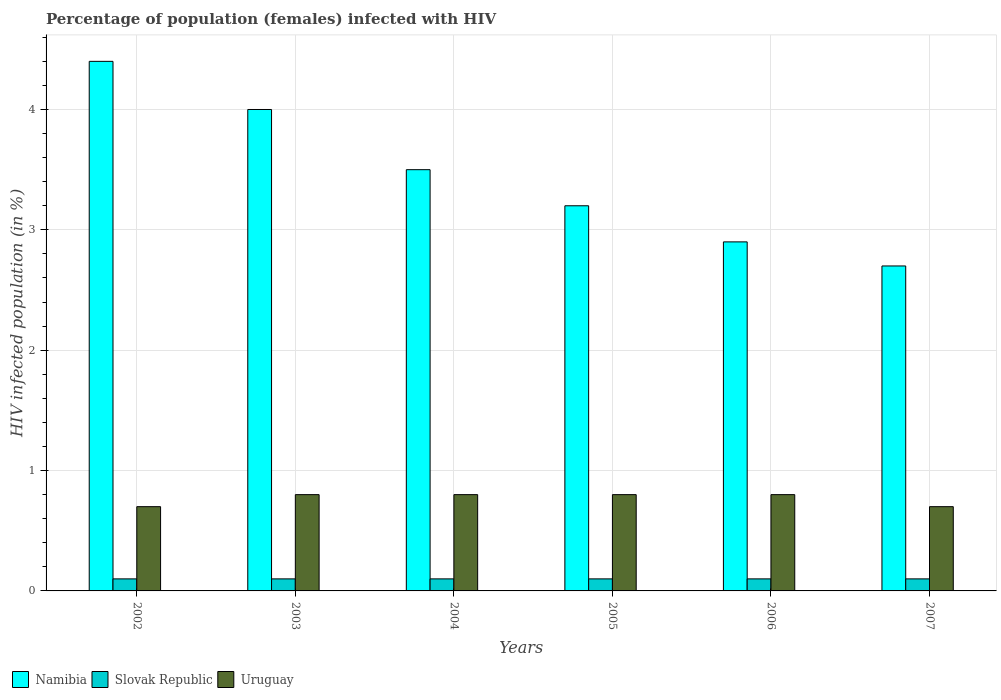How many groups of bars are there?
Provide a short and direct response. 6. Are the number of bars per tick equal to the number of legend labels?
Keep it short and to the point. Yes. Are the number of bars on each tick of the X-axis equal?
Offer a very short reply. Yes. What is the label of the 4th group of bars from the left?
Your answer should be compact. 2005. What is the percentage of HIV infected female population in Namibia in 2002?
Make the answer very short. 4.4. Across all years, what is the maximum percentage of HIV infected female population in Namibia?
Ensure brevity in your answer.  4.4. Across all years, what is the minimum percentage of HIV infected female population in Namibia?
Your answer should be compact. 2.7. In which year was the percentage of HIV infected female population in Slovak Republic maximum?
Give a very brief answer. 2002. What is the difference between the percentage of HIV infected female population in Slovak Republic in 2006 and that in 2007?
Your answer should be compact. 0. What is the difference between the percentage of HIV infected female population in Namibia in 2007 and the percentage of HIV infected female population in Slovak Republic in 2002?
Make the answer very short. 2.6. What is the average percentage of HIV infected female population in Slovak Republic per year?
Offer a terse response. 0.1. In the year 2005, what is the difference between the percentage of HIV infected female population in Slovak Republic and percentage of HIV infected female population in Uruguay?
Provide a succinct answer. -0.7. Is the percentage of HIV infected female population in Uruguay in 2002 less than that in 2004?
Offer a terse response. Yes. Is the difference between the percentage of HIV infected female population in Slovak Republic in 2004 and 2007 greater than the difference between the percentage of HIV infected female population in Uruguay in 2004 and 2007?
Your answer should be very brief. No. What is the difference between the highest and the lowest percentage of HIV infected female population in Uruguay?
Your answer should be compact. 0.1. In how many years, is the percentage of HIV infected female population in Uruguay greater than the average percentage of HIV infected female population in Uruguay taken over all years?
Make the answer very short. 4. What does the 1st bar from the left in 2002 represents?
Provide a succinct answer. Namibia. What does the 2nd bar from the right in 2003 represents?
Keep it short and to the point. Slovak Republic. Is it the case that in every year, the sum of the percentage of HIV infected female population in Uruguay and percentage of HIV infected female population in Namibia is greater than the percentage of HIV infected female population in Slovak Republic?
Offer a very short reply. Yes. How many bars are there?
Your answer should be compact. 18. How many years are there in the graph?
Ensure brevity in your answer.  6. What is the difference between two consecutive major ticks on the Y-axis?
Ensure brevity in your answer.  1. Are the values on the major ticks of Y-axis written in scientific E-notation?
Keep it short and to the point. No. Does the graph contain any zero values?
Your response must be concise. No. Does the graph contain grids?
Your response must be concise. Yes. Where does the legend appear in the graph?
Provide a succinct answer. Bottom left. How many legend labels are there?
Offer a very short reply. 3. How are the legend labels stacked?
Ensure brevity in your answer.  Horizontal. What is the title of the graph?
Ensure brevity in your answer.  Percentage of population (females) infected with HIV. What is the label or title of the Y-axis?
Offer a very short reply. HIV infected population (in %). What is the HIV infected population (in %) in Namibia in 2002?
Provide a succinct answer. 4.4. What is the HIV infected population (in %) in Slovak Republic in 2002?
Keep it short and to the point. 0.1. What is the HIV infected population (in %) in Uruguay in 2002?
Ensure brevity in your answer.  0.7. What is the HIV infected population (in %) of Uruguay in 2003?
Provide a short and direct response. 0.8. What is the HIV infected population (in %) of Slovak Republic in 2004?
Make the answer very short. 0.1. What is the HIV infected population (in %) of Slovak Republic in 2005?
Offer a very short reply. 0.1. What is the HIV infected population (in %) of Uruguay in 2005?
Provide a short and direct response. 0.8. What is the HIV infected population (in %) in Namibia in 2006?
Give a very brief answer. 2.9. What is the HIV infected population (in %) of Slovak Republic in 2006?
Offer a terse response. 0.1. What is the HIV infected population (in %) of Namibia in 2007?
Your response must be concise. 2.7. Across all years, what is the maximum HIV infected population (in %) of Namibia?
Your answer should be very brief. 4.4. Across all years, what is the maximum HIV infected population (in %) of Slovak Republic?
Your answer should be very brief. 0.1. Across all years, what is the maximum HIV infected population (in %) of Uruguay?
Your answer should be compact. 0.8. Across all years, what is the minimum HIV infected population (in %) of Namibia?
Give a very brief answer. 2.7. Across all years, what is the minimum HIV infected population (in %) in Slovak Republic?
Provide a short and direct response. 0.1. Across all years, what is the minimum HIV infected population (in %) of Uruguay?
Offer a terse response. 0.7. What is the total HIV infected population (in %) in Namibia in the graph?
Offer a very short reply. 20.7. What is the total HIV infected population (in %) in Uruguay in the graph?
Ensure brevity in your answer.  4.6. What is the difference between the HIV infected population (in %) in Namibia in 2002 and that in 2003?
Keep it short and to the point. 0.4. What is the difference between the HIV infected population (in %) in Uruguay in 2002 and that in 2003?
Give a very brief answer. -0.1. What is the difference between the HIV infected population (in %) in Uruguay in 2002 and that in 2004?
Your answer should be very brief. -0.1. What is the difference between the HIV infected population (in %) in Namibia in 2002 and that in 2005?
Ensure brevity in your answer.  1.2. What is the difference between the HIV infected population (in %) of Namibia in 2002 and that in 2006?
Provide a succinct answer. 1.5. What is the difference between the HIV infected population (in %) of Slovak Republic in 2002 and that in 2006?
Offer a terse response. 0. What is the difference between the HIV infected population (in %) in Uruguay in 2002 and that in 2007?
Offer a terse response. 0. What is the difference between the HIV infected population (in %) in Namibia in 2003 and that in 2004?
Make the answer very short. 0.5. What is the difference between the HIV infected population (in %) of Uruguay in 2003 and that in 2006?
Your answer should be very brief. 0. What is the difference between the HIV infected population (in %) in Slovak Republic in 2003 and that in 2007?
Your answer should be compact. 0. What is the difference between the HIV infected population (in %) of Slovak Republic in 2004 and that in 2006?
Provide a short and direct response. 0. What is the difference between the HIV infected population (in %) of Namibia in 2004 and that in 2007?
Offer a terse response. 0.8. What is the difference between the HIV infected population (in %) in Slovak Republic in 2004 and that in 2007?
Provide a succinct answer. 0. What is the difference between the HIV infected population (in %) in Uruguay in 2004 and that in 2007?
Make the answer very short. 0.1. What is the difference between the HIV infected population (in %) of Namibia in 2005 and that in 2006?
Provide a succinct answer. 0.3. What is the difference between the HIV infected population (in %) of Slovak Republic in 2005 and that in 2006?
Ensure brevity in your answer.  0. What is the difference between the HIV infected population (in %) in Namibia in 2006 and that in 2007?
Your answer should be very brief. 0.2. What is the difference between the HIV infected population (in %) in Slovak Republic in 2006 and that in 2007?
Your answer should be very brief. 0. What is the difference between the HIV infected population (in %) in Namibia in 2002 and the HIV infected population (in %) in Slovak Republic in 2003?
Ensure brevity in your answer.  4.3. What is the difference between the HIV infected population (in %) in Slovak Republic in 2002 and the HIV infected population (in %) in Uruguay in 2003?
Give a very brief answer. -0.7. What is the difference between the HIV infected population (in %) of Namibia in 2002 and the HIV infected population (in %) of Slovak Republic in 2004?
Give a very brief answer. 4.3. What is the difference between the HIV infected population (in %) of Namibia in 2002 and the HIV infected population (in %) of Slovak Republic in 2005?
Your response must be concise. 4.3. What is the difference between the HIV infected population (in %) of Namibia in 2002 and the HIV infected population (in %) of Uruguay in 2005?
Your answer should be compact. 3.6. What is the difference between the HIV infected population (in %) of Slovak Republic in 2002 and the HIV infected population (in %) of Uruguay in 2005?
Give a very brief answer. -0.7. What is the difference between the HIV infected population (in %) in Namibia in 2002 and the HIV infected population (in %) in Slovak Republic in 2007?
Make the answer very short. 4.3. What is the difference between the HIV infected population (in %) of Slovak Republic in 2002 and the HIV infected population (in %) of Uruguay in 2007?
Offer a very short reply. -0.6. What is the difference between the HIV infected population (in %) of Namibia in 2003 and the HIV infected population (in %) of Slovak Republic in 2004?
Provide a short and direct response. 3.9. What is the difference between the HIV infected population (in %) of Slovak Republic in 2003 and the HIV infected population (in %) of Uruguay in 2004?
Provide a short and direct response. -0.7. What is the difference between the HIV infected population (in %) of Namibia in 2003 and the HIV infected population (in %) of Uruguay in 2005?
Provide a short and direct response. 3.2. What is the difference between the HIV infected population (in %) of Namibia in 2003 and the HIV infected population (in %) of Uruguay in 2006?
Your answer should be compact. 3.2. What is the difference between the HIV infected population (in %) in Slovak Republic in 2003 and the HIV infected population (in %) in Uruguay in 2006?
Make the answer very short. -0.7. What is the difference between the HIV infected population (in %) of Namibia in 2003 and the HIV infected population (in %) of Slovak Republic in 2007?
Keep it short and to the point. 3.9. What is the difference between the HIV infected population (in %) in Namibia in 2003 and the HIV infected population (in %) in Uruguay in 2007?
Give a very brief answer. 3.3. What is the difference between the HIV infected population (in %) of Slovak Republic in 2003 and the HIV infected population (in %) of Uruguay in 2007?
Ensure brevity in your answer.  -0.6. What is the difference between the HIV infected population (in %) in Namibia in 2004 and the HIV infected population (in %) in Uruguay in 2005?
Ensure brevity in your answer.  2.7. What is the difference between the HIV infected population (in %) in Namibia in 2004 and the HIV infected population (in %) in Slovak Republic in 2006?
Give a very brief answer. 3.4. What is the difference between the HIV infected population (in %) in Namibia in 2004 and the HIV infected population (in %) in Uruguay in 2006?
Give a very brief answer. 2.7. What is the difference between the HIV infected population (in %) of Namibia in 2004 and the HIV infected population (in %) of Slovak Republic in 2007?
Offer a very short reply. 3.4. What is the difference between the HIV infected population (in %) in Namibia in 2005 and the HIV infected population (in %) in Slovak Republic in 2006?
Provide a short and direct response. 3.1. What is the difference between the HIV infected population (in %) in Namibia in 2005 and the HIV infected population (in %) in Uruguay in 2006?
Provide a short and direct response. 2.4. What is the difference between the HIV infected population (in %) of Slovak Republic in 2005 and the HIV infected population (in %) of Uruguay in 2006?
Give a very brief answer. -0.7. What is the difference between the HIV infected population (in %) in Namibia in 2005 and the HIV infected population (in %) in Slovak Republic in 2007?
Ensure brevity in your answer.  3.1. What is the difference between the HIV infected population (in %) of Namibia in 2005 and the HIV infected population (in %) of Uruguay in 2007?
Your answer should be very brief. 2.5. What is the difference between the HIV infected population (in %) of Namibia in 2006 and the HIV infected population (in %) of Slovak Republic in 2007?
Your answer should be compact. 2.8. What is the difference between the HIV infected population (in %) of Namibia in 2006 and the HIV infected population (in %) of Uruguay in 2007?
Your answer should be very brief. 2.2. What is the difference between the HIV infected population (in %) in Slovak Republic in 2006 and the HIV infected population (in %) in Uruguay in 2007?
Your answer should be very brief. -0.6. What is the average HIV infected population (in %) in Namibia per year?
Ensure brevity in your answer.  3.45. What is the average HIV infected population (in %) in Uruguay per year?
Offer a very short reply. 0.77. In the year 2002, what is the difference between the HIV infected population (in %) of Namibia and HIV infected population (in %) of Uruguay?
Offer a terse response. 3.7. In the year 2003, what is the difference between the HIV infected population (in %) in Namibia and HIV infected population (in %) in Uruguay?
Make the answer very short. 3.2. In the year 2005, what is the difference between the HIV infected population (in %) of Namibia and HIV infected population (in %) of Uruguay?
Provide a short and direct response. 2.4. In the year 2006, what is the difference between the HIV infected population (in %) of Namibia and HIV infected population (in %) of Slovak Republic?
Your answer should be compact. 2.8. In the year 2006, what is the difference between the HIV infected population (in %) in Slovak Republic and HIV infected population (in %) in Uruguay?
Your response must be concise. -0.7. What is the ratio of the HIV infected population (in %) of Slovak Republic in 2002 to that in 2003?
Offer a terse response. 1. What is the ratio of the HIV infected population (in %) in Uruguay in 2002 to that in 2003?
Keep it short and to the point. 0.88. What is the ratio of the HIV infected population (in %) in Namibia in 2002 to that in 2004?
Provide a succinct answer. 1.26. What is the ratio of the HIV infected population (in %) in Namibia in 2002 to that in 2005?
Your answer should be compact. 1.38. What is the ratio of the HIV infected population (in %) of Slovak Republic in 2002 to that in 2005?
Ensure brevity in your answer.  1. What is the ratio of the HIV infected population (in %) of Uruguay in 2002 to that in 2005?
Offer a terse response. 0.88. What is the ratio of the HIV infected population (in %) in Namibia in 2002 to that in 2006?
Give a very brief answer. 1.52. What is the ratio of the HIV infected population (in %) of Uruguay in 2002 to that in 2006?
Ensure brevity in your answer.  0.88. What is the ratio of the HIV infected population (in %) in Namibia in 2002 to that in 2007?
Provide a short and direct response. 1.63. What is the ratio of the HIV infected population (in %) in Namibia in 2003 to that in 2004?
Ensure brevity in your answer.  1.14. What is the ratio of the HIV infected population (in %) in Slovak Republic in 2003 to that in 2005?
Your answer should be compact. 1. What is the ratio of the HIV infected population (in %) of Namibia in 2003 to that in 2006?
Provide a succinct answer. 1.38. What is the ratio of the HIV infected population (in %) of Slovak Republic in 2003 to that in 2006?
Provide a short and direct response. 1. What is the ratio of the HIV infected population (in %) of Namibia in 2003 to that in 2007?
Your answer should be compact. 1.48. What is the ratio of the HIV infected population (in %) of Slovak Republic in 2003 to that in 2007?
Give a very brief answer. 1. What is the ratio of the HIV infected population (in %) in Namibia in 2004 to that in 2005?
Ensure brevity in your answer.  1.09. What is the ratio of the HIV infected population (in %) of Uruguay in 2004 to that in 2005?
Offer a very short reply. 1. What is the ratio of the HIV infected population (in %) of Namibia in 2004 to that in 2006?
Ensure brevity in your answer.  1.21. What is the ratio of the HIV infected population (in %) in Namibia in 2004 to that in 2007?
Offer a very short reply. 1.3. What is the ratio of the HIV infected population (in %) in Slovak Republic in 2004 to that in 2007?
Your answer should be very brief. 1. What is the ratio of the HIV infected population (in %) of Namibia in 2005 to that in 2006?
Provide a succinct answer. 1.1. What is the ratio of the HIV infected population (in %) in Slovak Republic in 2005 to that in 2006?
Give a very brief answer. 1. What is the ratio of the HIV infected population (in %) of Namibia in 2005 to that in 2007?
Offer a terse response. 1.19. What is the ratio of the HIV infected population (in %) in Namibia in 2006 to that in 2007?
Offer a very short reply. 1.07. What is the ratio of the HIV infected population (in %) in Slovak Republic in 2006 to that in 2007?
Make the answer very short. 1. What is the difference between the highest and the lowest HIV infected population (in %) of Slovak Republic?
Ensure brevity in your answer.  0. 